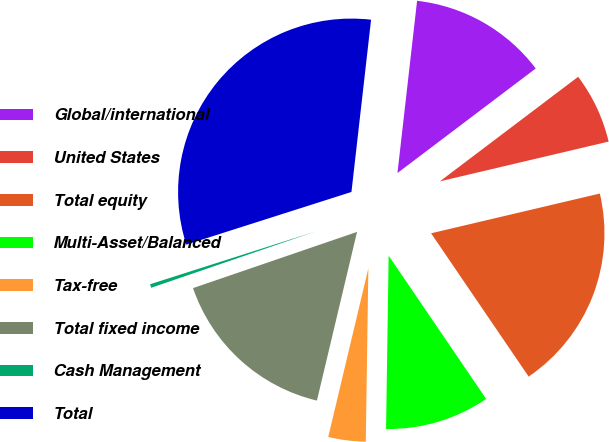<chart> <loc_0><loc_0><loc_500><loc_500><pie_chart><fcel>Global/international<fcel>United States<fcel>Total equity<fcel>Multi-Asset/Balanced<fcel>Tax-free<fcel>Total fixed income<fcel>Cash Management<fcel>Total<nl><fcel>12.89%<fcel>6.62%<fcel>19.17%<fcel>9.75%<fcel>3.48%<fcel>16.03%<fcel>0.34%<fcel>31.72%<nl></chart> 